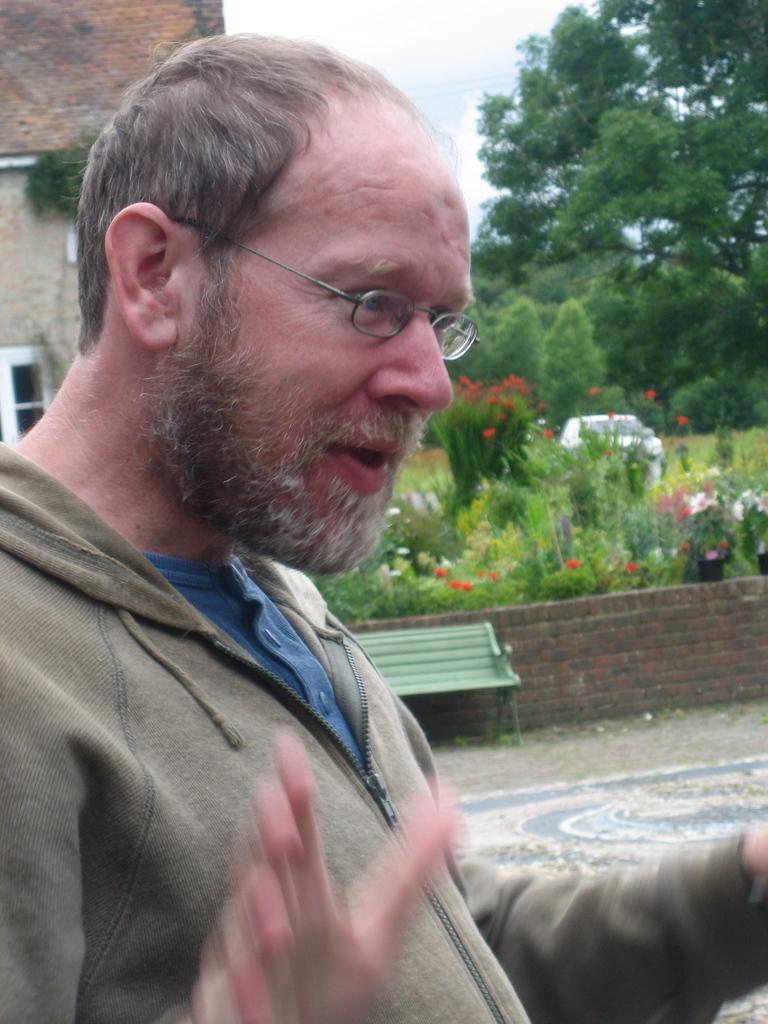Please provide a concise description of this image. In this image I can see a person is wearing brown jacket. Back I can see a building ,windows, bench, trees, few colorful flowers and sky is in white color. 